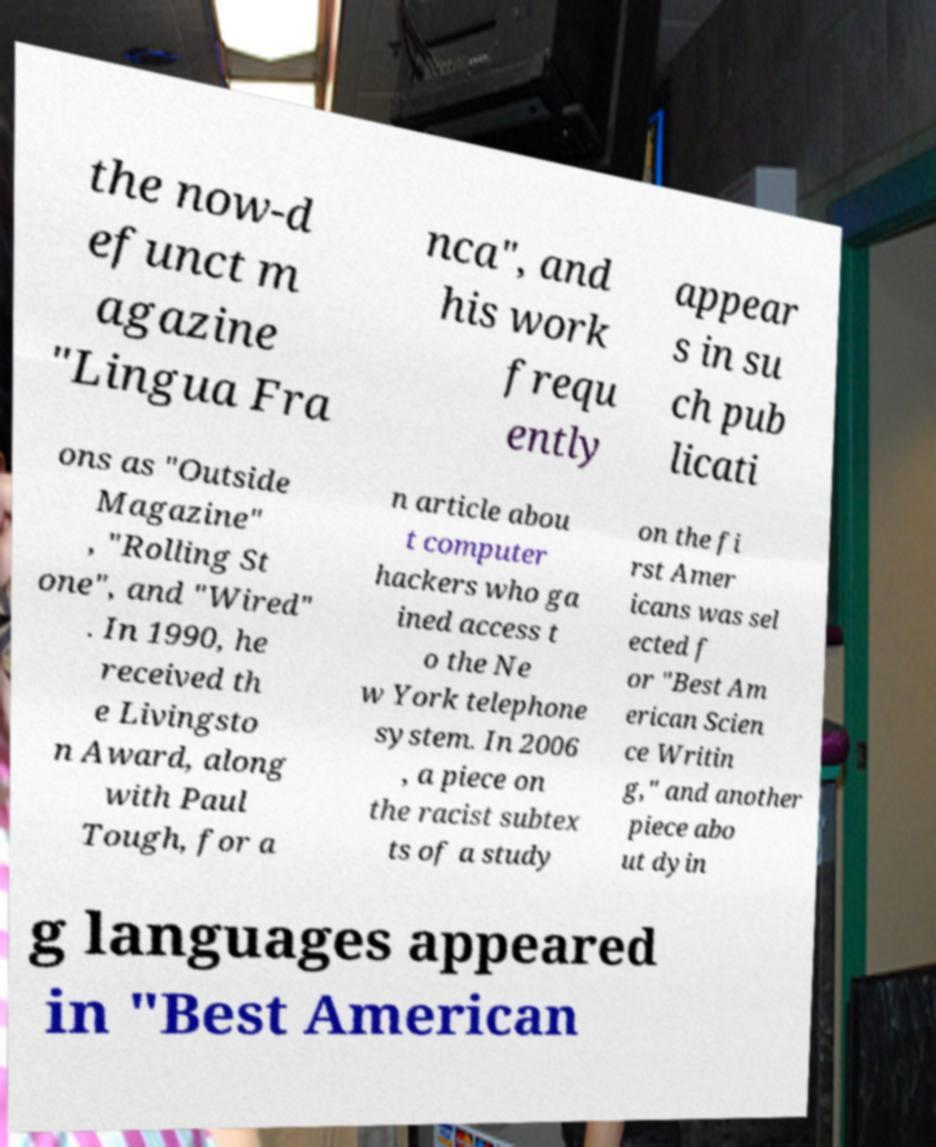Please identify and transcribe the text found in this image. the now-d efunct m agazine "Lingua Fra nca", and his work frequ ently appear s in su ch pub licati ons as "Outside Magazine" , "Rolling St one", and "Wired" . In 1990, he received th e Livingsto n Award, along with Paul Tough, for a n article abou t computer hackers who ga ined access t o the Ne w York telephone system. In 2006 , a piece on the racist subtex ts of a study on the fi rst Amer icans was sel ected f or "Best Am erican Scien ce Writin g," and another piece abo ut dyin g languages appeared in "Best American 